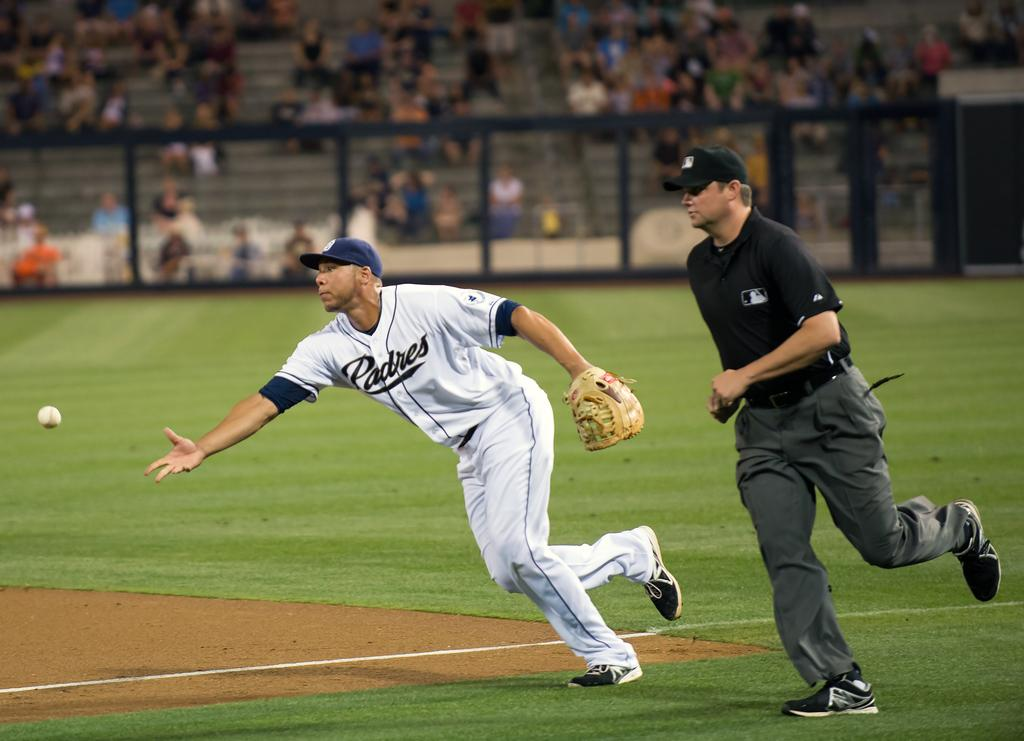Provide a one-sentence caption for the provided image. A player for padres throws the ball with a referee chasing behind him. 